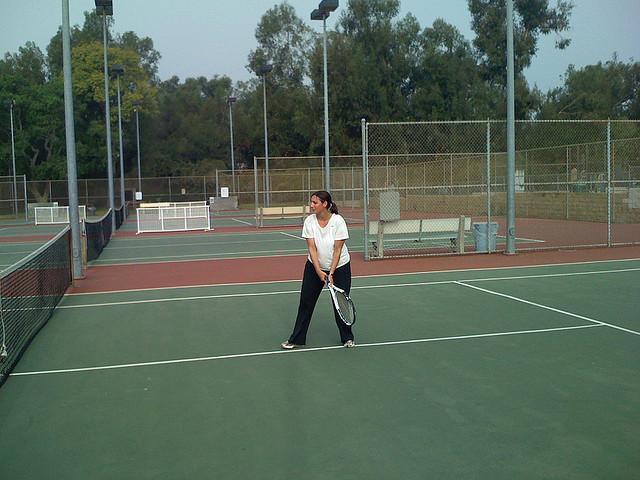What are the tall silver poles used for?
Indicate the correct response by choosing from the four available options to answer the question.
Options: Targets, swinging, climbing, lighting. Lighting. 